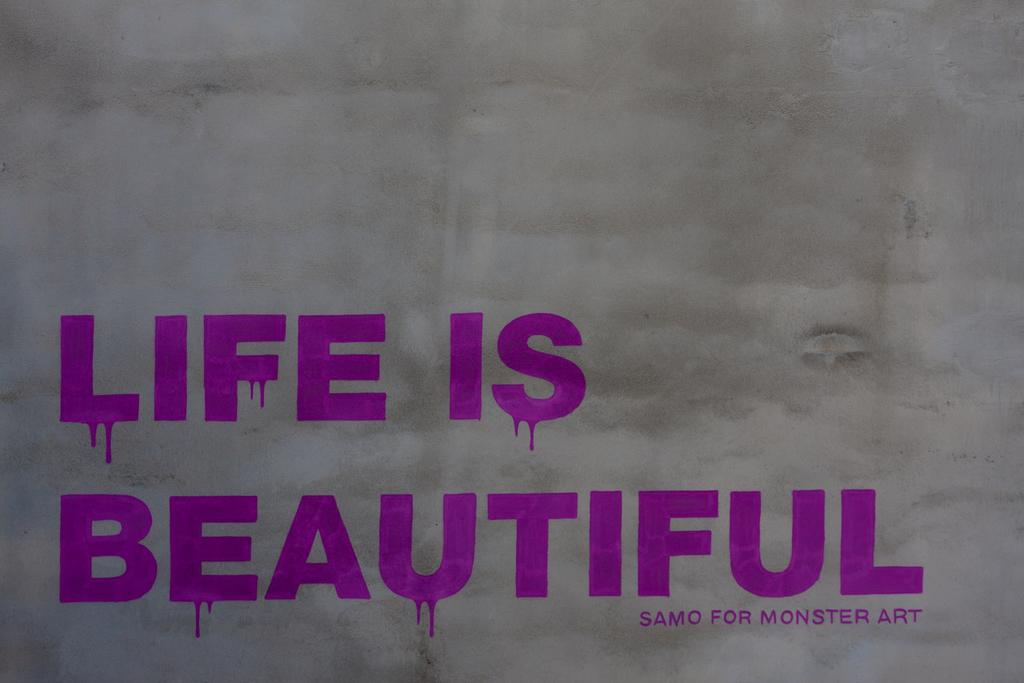Provide a one-sentence caption for the provided image. A gray sign that says life is beautiful in purple. 